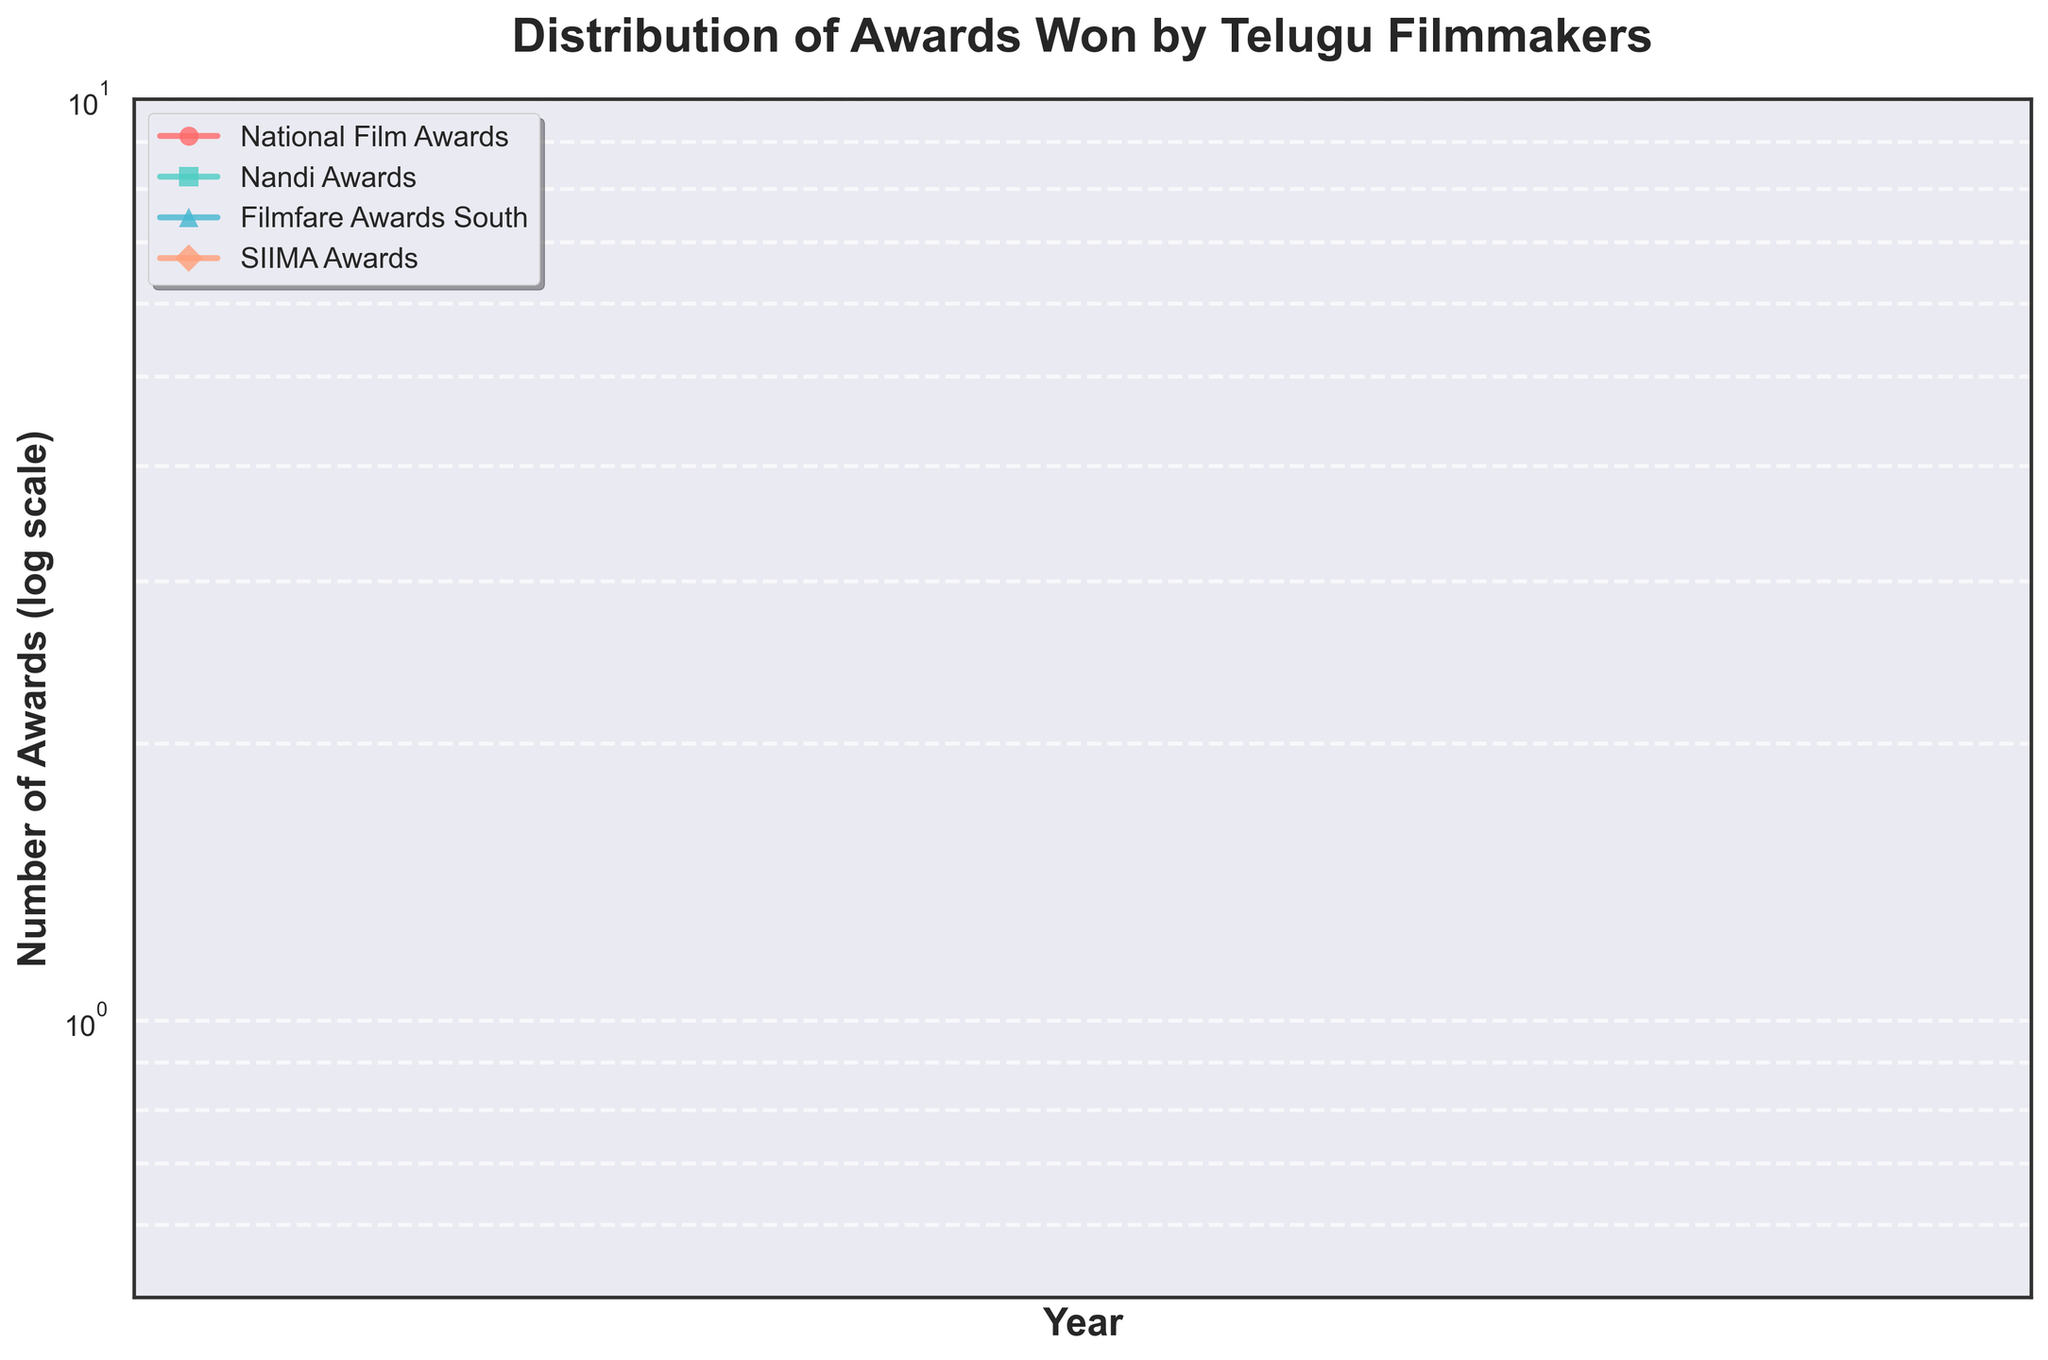How many types of awards are shown in the figure? The figure depicts four types of awards, as indicated by the four different colors and markers in the plot. The legend names them: National Film Awards, Nandi Awards, Filmfare Awards South, and SIIMA Awards.
Answer: Four types Which award had the highest number in 2020? Looking at the plotted lines and markers for 2020, the National Film Awards had the highest number compared to the other award types, reaching six awards.
Answer: National Film Awards What is the trend of the SIIMA Awards from 2003 to 2021? Observing the plotted line for the SIIMA Awards, it started around one award in 2003 and shows a general increasing trend, reaching four awards in 2021 with slight fluctuations in between.
Answer: Increasing trend Which years had the same number of National Film Awards? The plotted markers for National Film Awards show that the years 2003 and 2010 both had two awards.
Answer: 2003 and 2010 How do the awards in 2015 differ between Nandi Awards and Filmfare Awards South? According to the plotted markers for 2015, Nandi Awards had four while Filmfare Awards South had four as well. They are equal in number for that year.
Answer: No difference What is the overall trend for Nandi Awards from 2000 to 2021? Examining the log-scale plot for Nandi Awards, the number fluctuates but shows a slight increasing trend over the years, starting from three in 2000 and generally peaking at six on several occasions in later years.
Answer: Increasing trend Which year had the maximum sum of all award types combined? Summing up each year's award types: 
For 2020: (6 + 6 + 5 + 3) = 20, which is greater than any other year when visually cross-referencing sums.
Answer: 2020 Which award type had the most significant increase between two consecutive years, and which years were they? By inspecting the plot lines and markers, Filmfare Awards South experienced the most notable increase from 2019 to 2020, with the number of awards rising from four to five.
Answer: Filmfare Awards South, 2019-2020 How many years had more than four types of awards each register above 2? By examining the log-scale plot for years where each award type exceeds 2:
Years 2020, 2021 fit this criterion.
Answer: Two years 